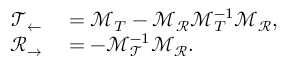<formula> <loc_0><loc_0><loc_500><loc_500>\begin{array} { r l } { \mathcal { T } _ { \leftarrow } } & = \mathcal { M } _ { T } - \mathcal { M } _ { \mathcal { R } } \mathcal { M } _ { T } ^ { - 1 } \mathcal { M } _ { \mathcal { R } } , } \\ { \mathcal { R } _ { \rightarrow } } & = - \mathcal { M } _ { \mathcal { T } } ^ { - 1 } \mathcal { M } _ { \mathcal { R } } . } \end{array}</formula> 